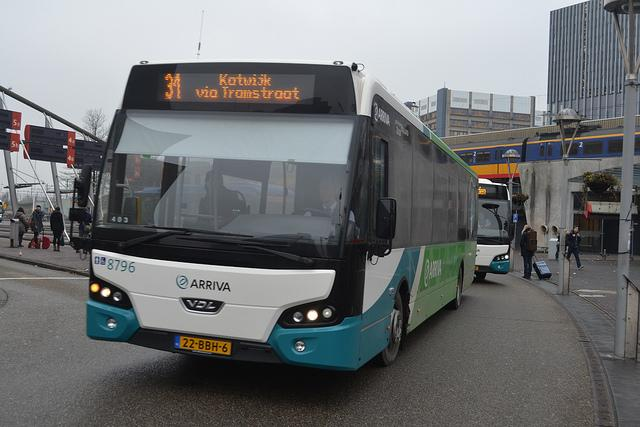Which animal would weigh more than this vehicle if it had no passengers? whale 